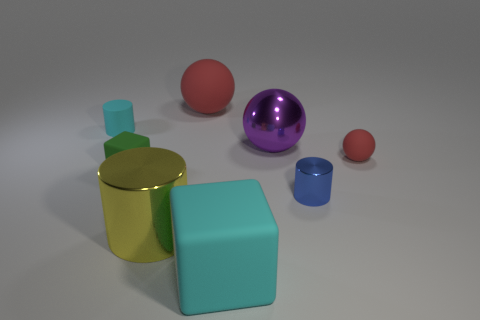Add 1 big purple metal things. How many objects exist? 9 Subtract all blocks. How many objects are left? 6 Subtract all purple objects. Subtract all large purple spheres. How many objects are left? 6 Add 6 purple things. How many purple things are left? 7 Add 2 small spheres. How many small spheres exist? 3 Subtract 1 red spheres. How many objects are left? 7 